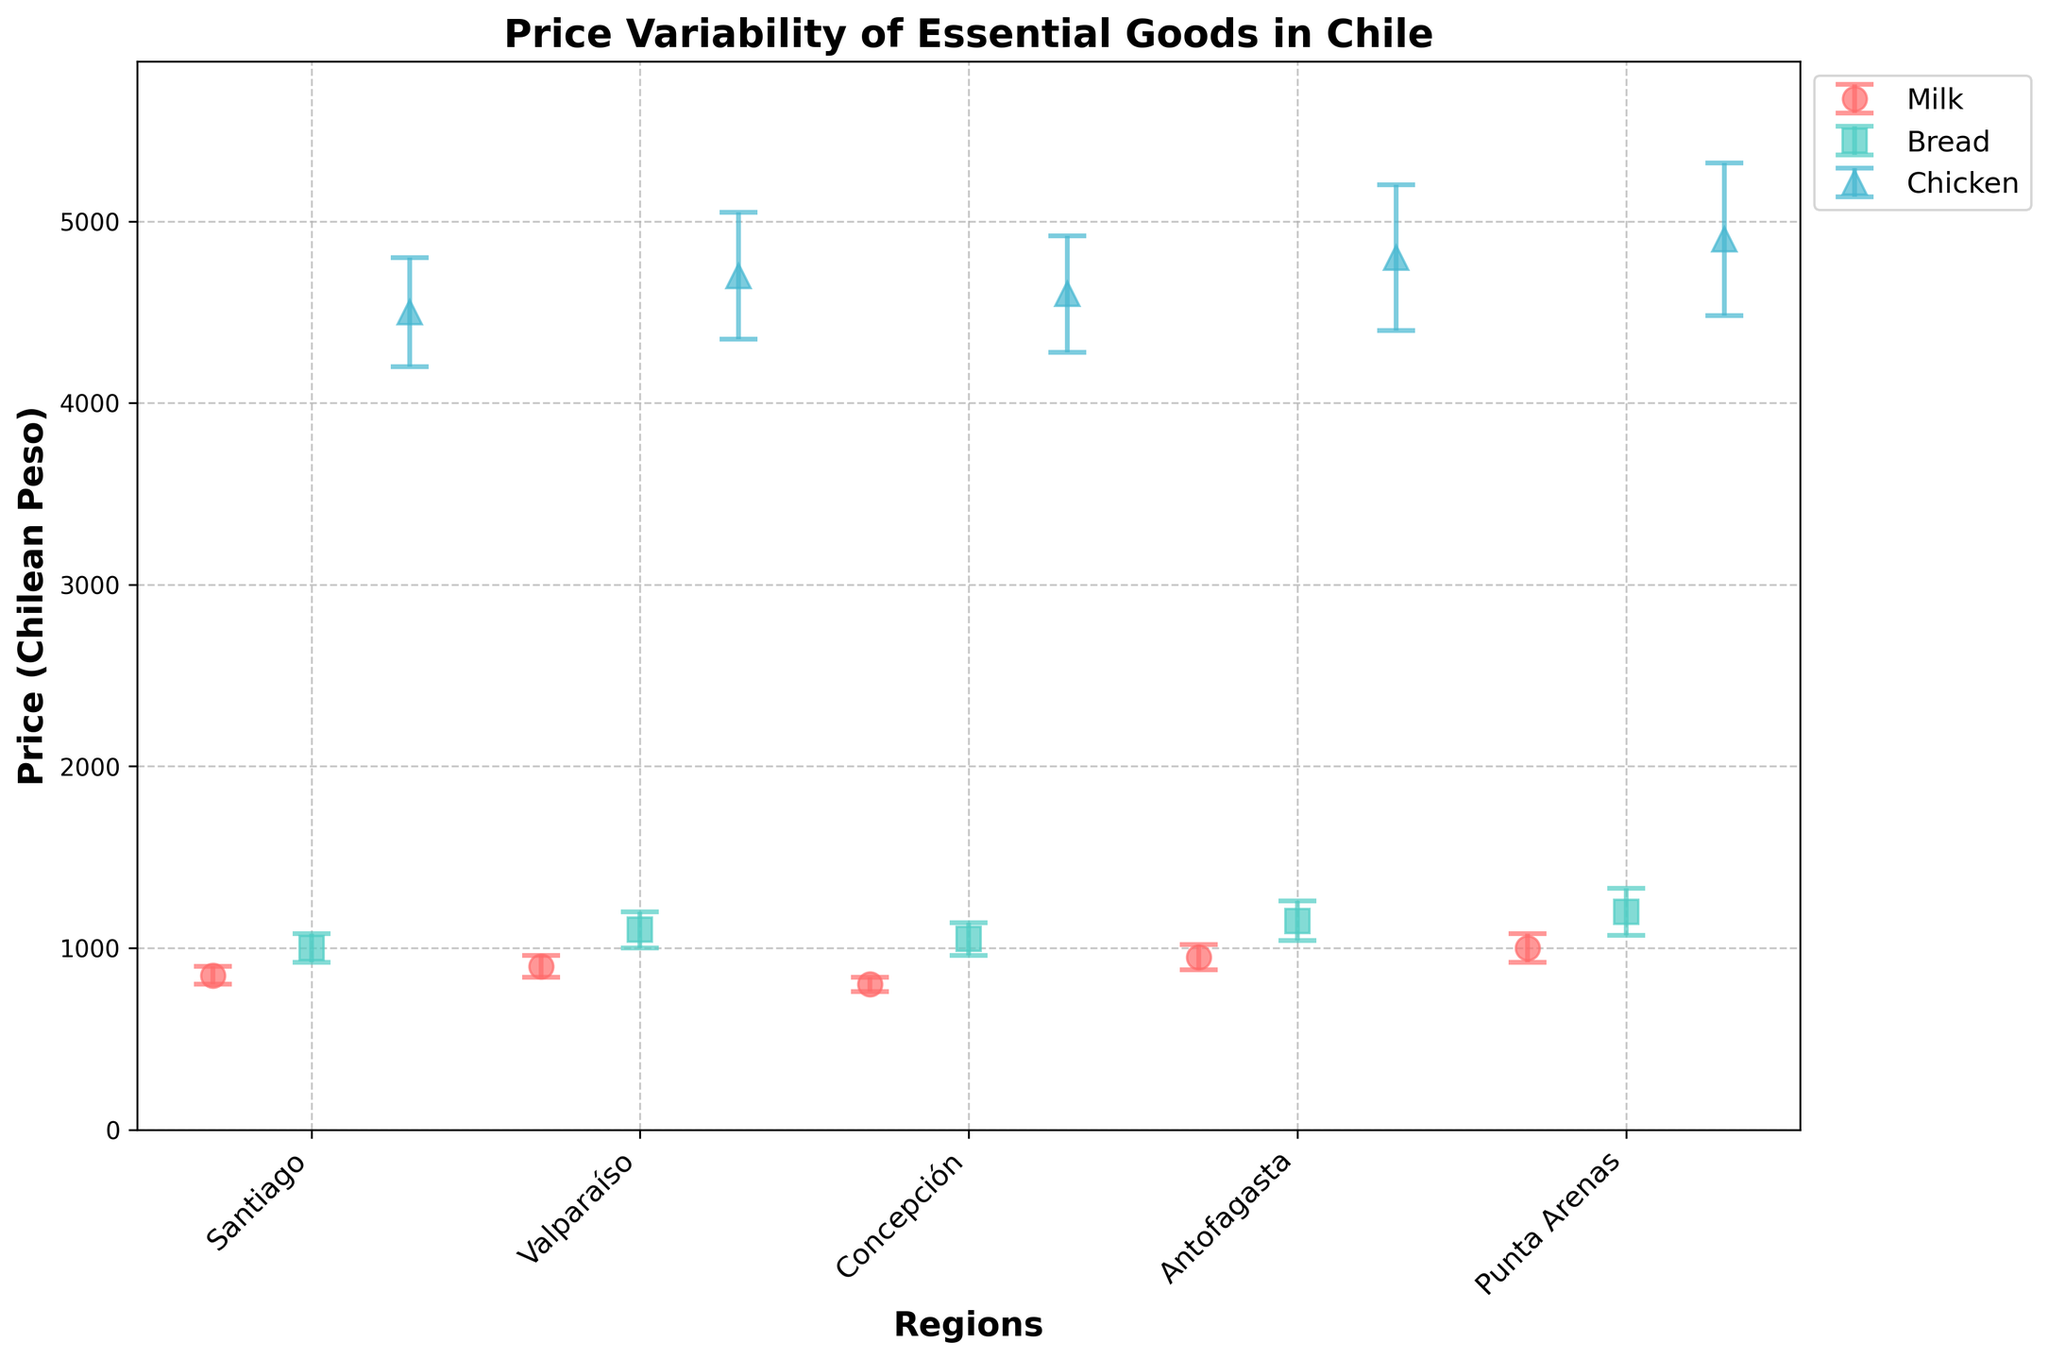What is the title of the figure? The title is given at the top of the figure and typically describes what the plot is about.
Answer: Price Variability of Essential Goods in Chile Which region has the highest average price for milk? To find this, look at the dot representing milk in each region and identify the one with the highest position on the y-axis.
Answer: Punta Arenas How does the price variability of bread in Concepción compare to that in Antofagasta? Compare the length of the error bars for bread in Concepción and Antofagasta. The region with a longer error bar has higher price variability.
Answer: Antofagasta What is the average price of chicken in Valparaíso? Locate the dot representing chicken in Valparaíso and read off the y-axis value.
Answer: 4700 Chilean Peso Which essential good shows the highest price variability in Santiago? Compare the lengths of the error bars for all essential goods in Santiago and identify which is the longest.
Answer: Chicken Is the average price of bread higher in Valparaíso or Concepción? Compare the positions of the dots representing the average price of bread in Valparaíso and Concepción. The higher dot indicates the higher price.
Answer: Valparaíso What is the range of average milk prices across all regions? Identify the highest and lowest milk prices from the y-axis values of the milk dots across all regions, then calculate the difference between them.
Answer: 1000 - 800 = 200 Chilean Peso Which essential good has the smallest price variability in any given region and what is it? Look for the smallest error bar across all goods and regions.
Answer: Milk in Concepción (variability = 40) What is the combined average price of milk and bread in Santiago? Find the y-axis values for milk and bread in Santiago and add them together.
Answer: 850 + 1000 = 1850 Chilean Peso Among the regions displayed, which one has the most consistent prices for essential goods? Identify the region where the error bars on average are the shortest across all essential goods, indicating lower price variability.
Answer: Concepción 